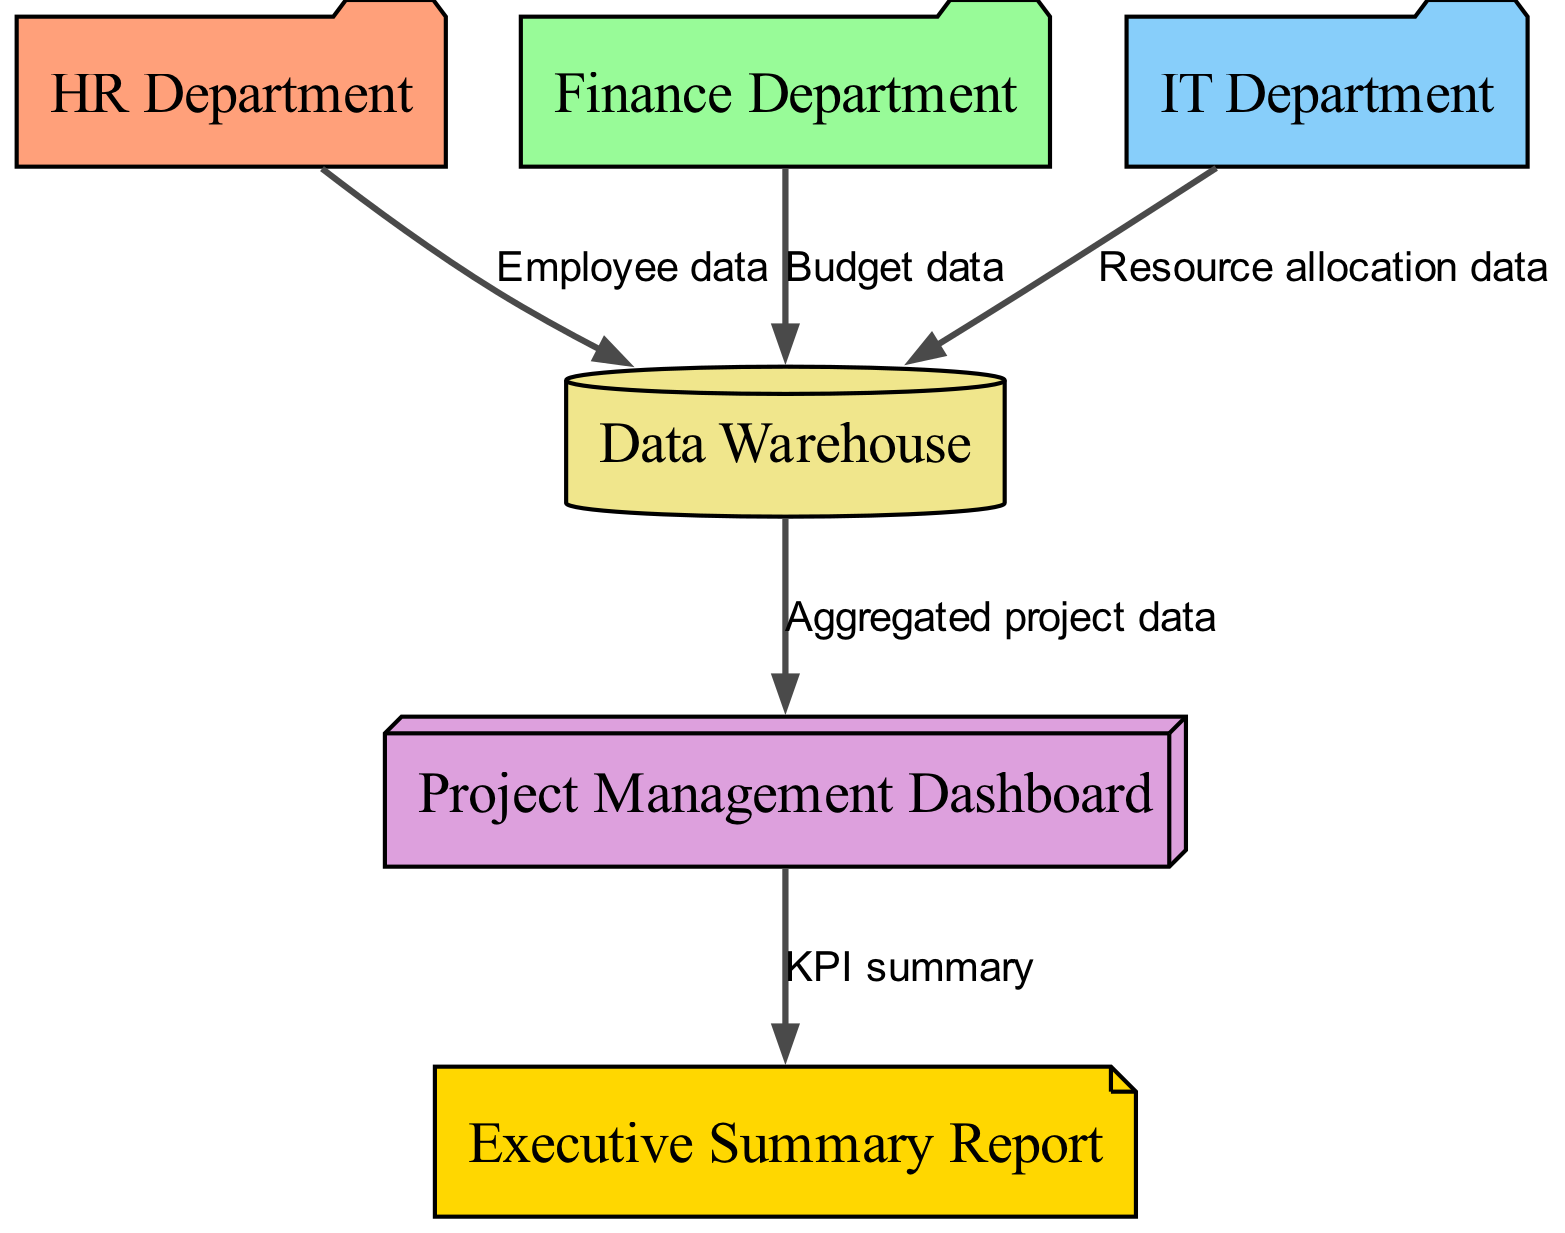What departments contribute data to the Data Warehouse? The diagram shows three departments contributing data to the Data Warehouse: HR Department, Finance Department, and IT Department. Each of these departments has an edge connecting to the Data Warehouse node, indicating the direction of data flow.
Answer: HR Department, Finance Department, IT Department What type of data does the HR Department send to the Data Warehouse? The specific edge from the HR Department to the Data Warehouse is labeled "Employee data." This label describes precisely what type of data is being aggregated from the HR Department into the Data Warehouse.
Answer: Employee data How many edges are there in the diagram? By counting the edges drawn in the diagram, there are a total of five edges connecting the various nodes. Each edge represents a distinct data flow from one component to another.
Answer: 5 What does the Data Warehouse send to the Project Management Dashboard? The edge connecting the Data Warehouse to the Project Management Dashboard is labeled "Aggregated project data," indicating this is the type of data passed from the Data Warehouse to the Dashboard.
Answer: Aggregated project data What is the final output of the Project Management Dashboard? The Project Management Dashboard sends out the "KPI summary" to the Executive Summary Report. This can be seen from the edge going from the Project Management Dashboard to the Executive Summary Report, representing the ultimate output.
Answer: KPI summary Which department's data relates to budget? The Finance Department's data is indicated by the edge labeled "Budget data" connecting it to the Data Warehouse. This shows that the Finance Department specifically contributes budget-related information.
Answer: Finance Department 